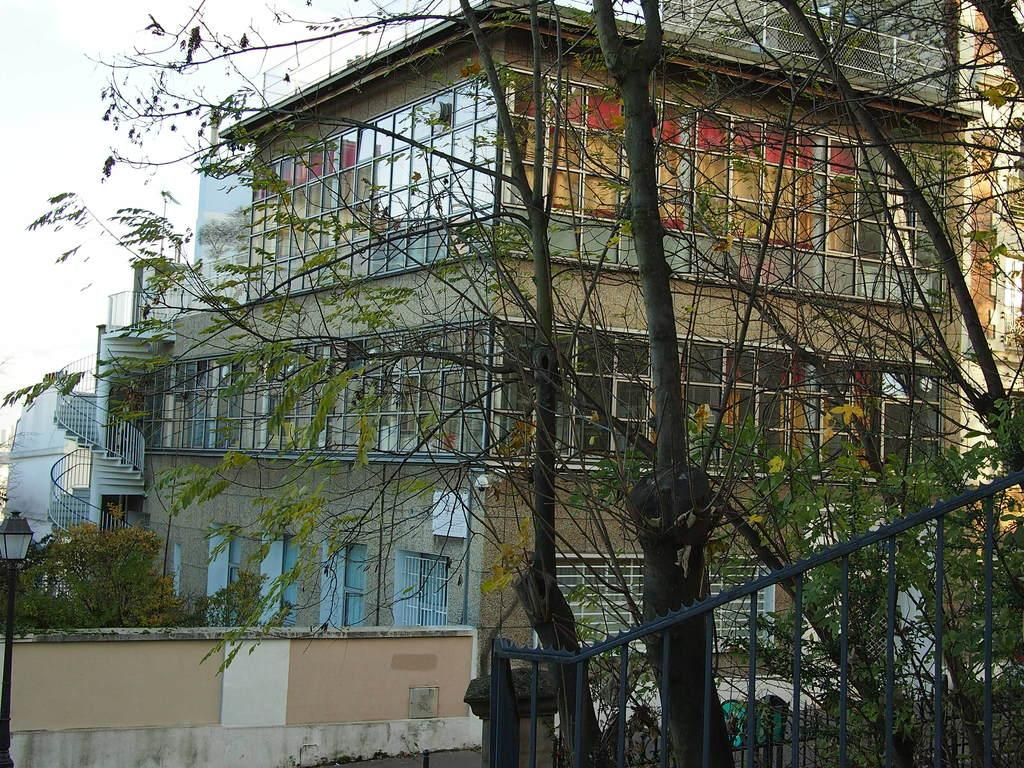What type of structure can be seen in the image? There is railing in the image, which suggests a structure like a balcony or staircase. What natural elements are present in the image? There are trees in the image. What man-made structures can be seen in the image? There are buildings in the image. What is visible in the background of the image? The sky is visible in the background of the image. What type of popcorn is being served at the event in the image? There is no event or popcorn present in the image; it features railing, trees, buildings, and the sky. Can you tell me how many achievers are visible in the image? There is no reference to any achievers in the image; it simply shows railing, trees, buildings, and the sky. 